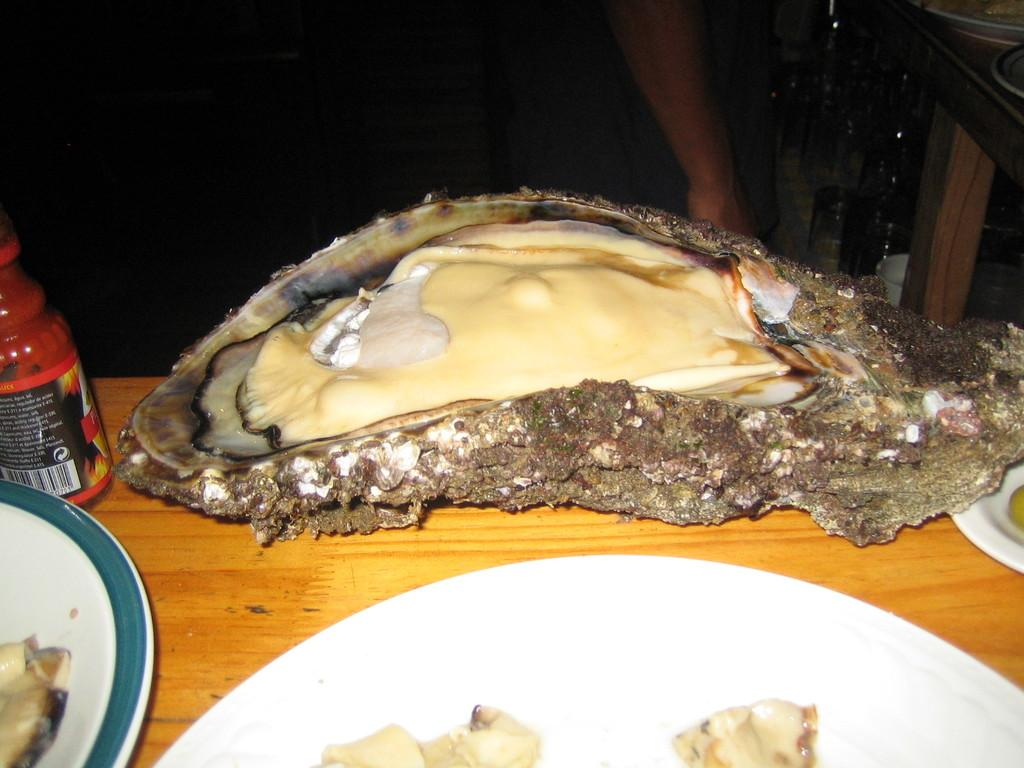What objects are present on the plates in the image? There is food on the plates in the image. What color is the prominent object in the image? There is a red object in the image. Can you describe the background of the image? The image has a dark background. Is there any indication of a person's presence in the image? Yes, a hand of a person is visible in the background. What type of wound can be seen on the person's hand in the image? There is no wound visible on the person's hand in the image. What committee is responsible for organizing the event in the image? There is no event or committee mentioned or depicted in the image. 